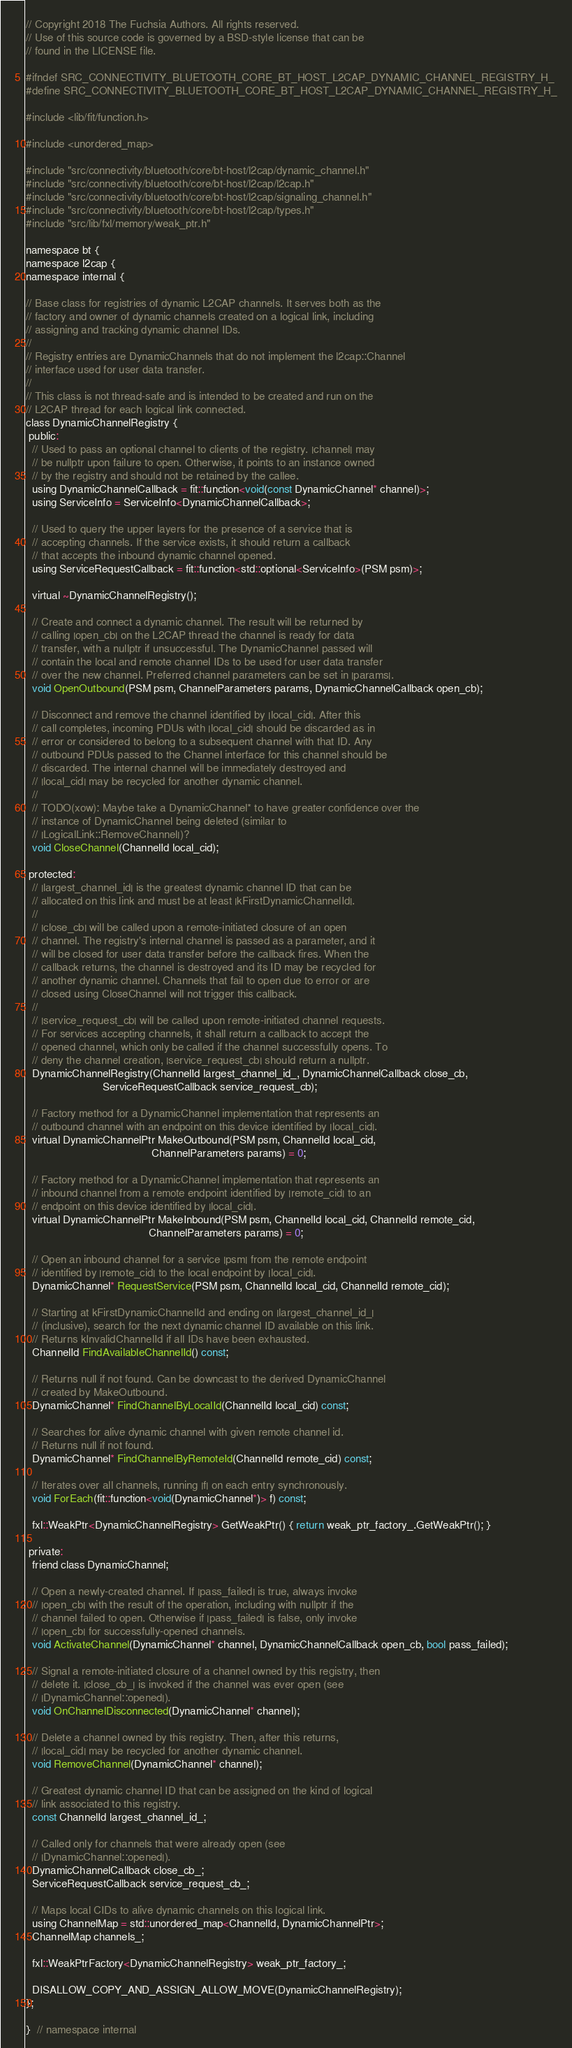Convert code to text. <code><loc_0><loc_0><loc_500><loc_500><_C_>// Copyright 2018 The Fuchsia Authors. All rights reserved.
// Use of this source code is governed by a BSD-style license that can be
// found in the LICENSE file.

#ifndef SRC_CONNECTIVITY_BLUETOOTH_CORE_BT_HOST_L2CAP_DYNAMIC_CHANNEL_REGISTRY_H_
#define SRC_CONNECTIVITY_BLUETOOTH_CORE_BT_HOST_L2CAP_DYNAMIC_CHANNEL_REGISTRY_H_

#include <lib/fit/function.h>

#include <unordered_map>

#include "src/connectivity/bluetooth/core/bt-host/l2cap/dynamic_channel.h"
#include "src/connectivity/bluetooth/core/bt-host/l2cap/l2cap.h"
#include "src/connectivity/bluetooth/core/bt-host/l2cap/signaling_channel.h"
#include "src/connectivity/bluetooth/core/bt-host/l2cap/types.h"
#include "src/lib/fxl/memory/weak_ptr.h"

namespace bt {
namespace l2cap {
namespace internal {

// Base class for registries of dynamic L2CAP channels. It serves both as the
// factory and owner of dynamic channels created on a logical link, including
// assigning and tracking dynamic channel IDs.
//
// Registry entries are DynamicChannels that do not implement the l2cap::Channel
// interface used for user data transfer.
//
// This class is not thread-safe and is intended to be created and run on the
// L2CAP thread for each logical link connected.
class DynamicChannelRegistry {
 public:
  // Used to pass an optional channel to clients of the registry. |channel| may
  // be nullptr upon failure to open. Otherwise, it points to an instance owned
  // by the registry and should not be retained by the callee.
  using DynamicChannelCallback = fit::function<void(const DynamicChannel* channel)>;
  using ServiceInfo = ServiceInfo<DynamicChannelCallback>;

  // Used to query the upper layers for the presence of a service that is
  // accepting channels. If the service exists, it should return a callback
  // that accepts the inbound dynamic channel opened.
  using ServiceRequestCallback = fit::function<std::optional<ServiceInfo>(PSM psm)>;

  virtual ~DynamicChannelRegistry();

  // Create and connect a dynamic channel. The result will be returned by
  // calling |open_cb| on the L2CAP thread the channel is ready for data
  // transfer, with a nullptr if unsuccessful. The DynamicChannel passed will
  // contain the local and remote channel IDs to be used for user data transfer
  // over the new channel. Preferred channel parameters can be set in |params|.
  void OpenOutbound(PSM psm, ChannelParameters params, DynamicChannelCallback open_cb);

  // Disconnect and remove the channel identified by |local_cid|. After this
  // call completes, incoming PDUs with |local_cid| should be discarded as in
  // error or considered to belong to a subsequent channel with that ID. Any
  // outbound PDUs passed to the Channel interface for this channel should be
  // discarded. The internal channel will be immediately destroyed and
  // |local_cid| may be recycled for another dynamic channel.
  //
  // TODO(xow): Maybe take a DynamicChannel* to have greater confidence over the
  // instance of DynamicChannel being deleted (similar to
  // |LogicalLink::RemoveChannel|)?
  void CloseChannel(ChannelId local_cid);

 protected:
  // |largest_channel_id| is the greatest dynamic channel ID that can be
  // allocated on this link and must be at least |kFirstDynamicChannelId|.
  //
  // |close_cb| will be called upon a remote-initiated closure of an open
  // channel. The registry's internal channel is passed as a parameter, and it
  // will be closed for user data transfer before the callback fires. When the
  // callback returns, the channel is destroyed and its ID may be recycled for
  // another dynamic channel. Channels that fail to open due to error or are
  // closed using CloseChannel will not trigger this callback.
  //
  // |service_request_cb| will be called upon remote-initiated channel requests.
  // For services accepting channels, it shall return a callback to accept the
  // opened channel, which only be called if the channel successfully opens. To
  // deny the channel creation, |service_request_cb| should return a nullptr.
  DynamicChannelRegistry(ChannelId largest_channel_id_, DynamicChannelCallback close_cb,
                         ServiceRequestCallback service_request_cb);

  // Factory method for a DynamicChannel implementation that represents an
  // outbound channel with an endpoint on this device identified by |local_cid|.
  virtual DynamicChannelPtr MakeOutbound(PSM psm, ChannelId local_cid,
                                         ChannelParameters params) = 0;

  // Factory method for a DynamicChannel implementation that represents an
  // inbound channel from a remote endpoint identified by |remote_cid| to an
  // endpoint on this device identified by |local_cid|.
  virtual DynamicChannelPtr MakeInbound(PSM psm, ChannelId local_cid, ChannelId remote_cid,
                                        ChannelParameters params) = 0;

  // Open an inbound channel for a service |psm| from the remote endpoint
  // identified by |remote_cid| to the local endpoint by |local_cid|.
  DynamicChannel* RequestService(PSM psm, ChannelId local_cid, ChannelId remote_cid);

  // Starting at kFirstDynamicChannelId and ending on |largest_channel_id_|
  // (inclusive), search for the next dynamic channel ID available on this link.
  // Returns kInvalidChannelId if all IDs have been exhausted.
  ChannelId FindAvailableChannelId() const;

  // Returns null if not found. Can be downcast to the derived DynamicChannel
  // created by MakeOutbound.
  DynamicChannel* FindChannelByLocalId(ChannelId local_cid) const;

  // Searches for alive dynamic channel with given remote channel id.
  // Returns null if not found.
  DynamicChannel* FindChannelByRemoteId(ChannelId remote_cid) const;

  // Iterates over all channels, running |f| on each entry synchronously.
  void ForEach(fit::function<void(DynamicChannel*)> f) const;

  fxl::WeakPtr<DynamicChannelRegistry> GetWeakPtr() { return weak_ptr_factory_.GetWeakPtr(); }

 private:
  friend class DynamicChannel;

  // Open a newly-created channel. If |pass_failed| is true, always invoke
  // |open_cb| with the result of the operation, including with nullptr if the
  // channel failed to open. Otherwise if |pass_failed| is false, only invoke
  // |open_cb| for successfully-opened channels.
  void ActivateChannel(DynamicChannel* channel, DynamicChannelCallback open_cb, bool pass_failed);

  // Signal a remote-initiated closure of a channel owned by this registry, then
  // delete it. |close_cb_| is invoked if the channel was ever open (see
  // |DynamicChannel::opened|).
  void OnChannelDisconnected(DynamicChannel* channel);

  // Delete a channel owned by this registry. Then, after this returns,
  // |local_cid| may be recycled for another dynamic channel.
  void RemoveChannel(DynamicChannel* channel);

  // Greatest dynamic channel ID that can be assigned on the kind of logical
  // link associated to this registry.
  const ChannelId largest_channel_id_;

  // Called only for channels that were already open (see
  // |DynamicChannel::opened|).
  DynamicChannelCallback close_cb_;
  ServiceRequestCallback service_request_cb_;

  // Maps local CIDs to alive dynamic channels on this logical link.
  using ChannelMap = std::unordered_map<ChannelId, DynamicChannelPtr>;
  ChannelMap channels_;

  fxl::WeakPtrFactory<DynamicChannelRegistry> weak_ptr_factory_;

  DISALLOW_COPY_AND_ASSIGN_ALLOW_MOVE(DynamicChannelRegistry);
};

}  // namespace internal</code> 